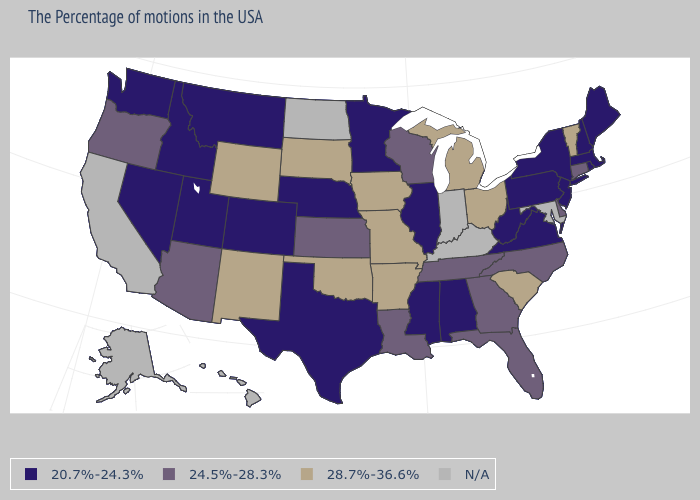What is the highest value in the South ?
Give a very brief answer. 28.7%-36.6%. Name the states that have a value in the range 24.5%-28.3%?
Be succinct. Connecticut, Delaware, North Carolina, Florida, Georgia, Tennessee, Wisconsin, Louisiana, Kansas, Arizona, Oregon. What is the value of New York?
Give a very brief answer. 20.7%-24.3%. Is the legend a continuous bar?
Concise answer only. No. Among the states that border Iowa , does Minnesota have the highest value?
Answer briefly. No. Does Washington have the lowest value in the West?
Write a very short answer. Yes. Does New Mexico have the lowest value in the West?
Keep it brief. No. What is the value of Oklahoma?
Give a very brief answer. 28.7%-36.6%. Name the states that have a value in the range 20.7%-24.3%?
Quick response, please. Maine, Massachusetts, Rhode Island, New Hampshire, New York, New Jersey, Pennsylvania, Virginia, West Virginia, Alabama, Illinois, Mississippi, Minnesota, Nebraska, Texas, Colorado, Utah, Montana, Idaho, Nevada, Washington. Does New Hampshire have the lowest value in the USA?
Short answer required. Yes. How many symbols are there in the legend?
Give a very brief answer. 4. Which states hav the highest value in the South?
Concise answer only. South Carolina, Arkansas, Oklahoma. What is the value of South Carolina?
Give a very brief answer. 28.7%-36.6%. 